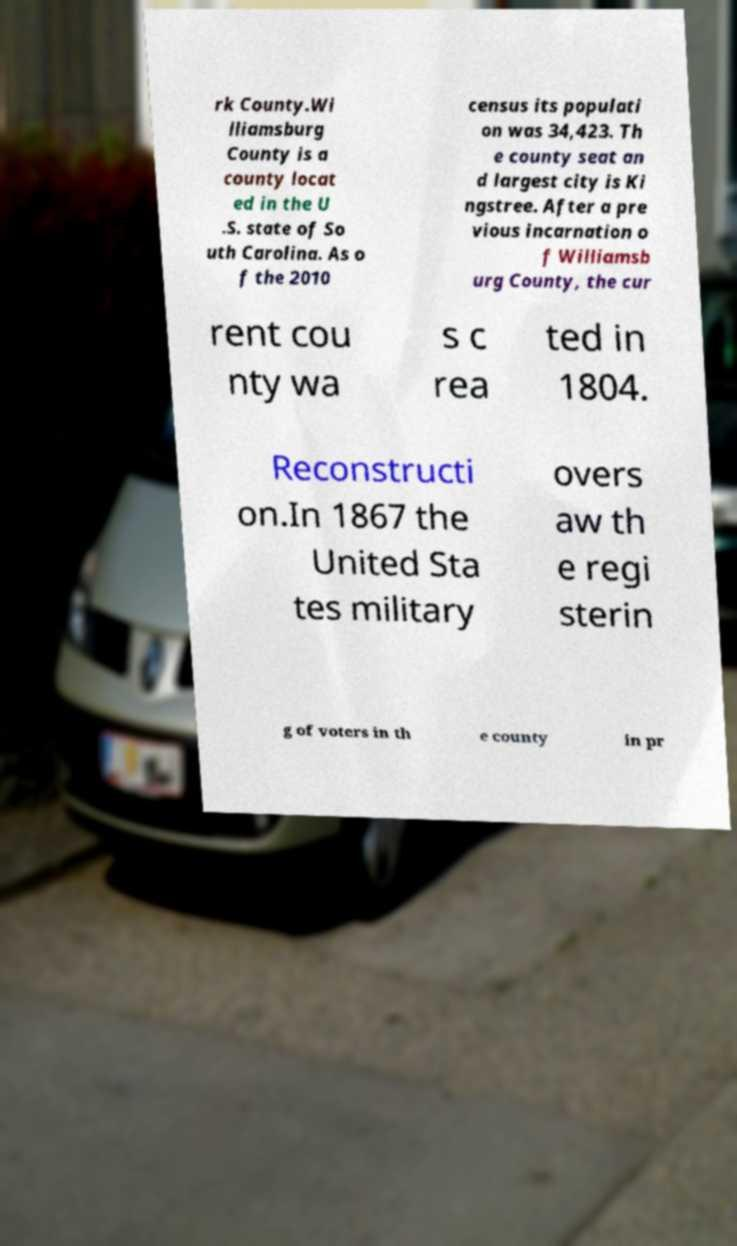For documentation purposes, I need the text within this image transcribed. Could you provide that? rk County.Wi lliamsburg County is a county locat ed in the U .S. state of So uth Carolina. As o f the 2010 census its populati on was 34,423. Th e county seat an d largest city is Ki ngstree. After a pre vious incarnation o f Williamsb urg County, the cur rent cou nty wa s c rea ted in 1804. Reconstructi on.In 1867 the United Sta tes military overs aw th e regi sterin g of voters in th e county in pr 